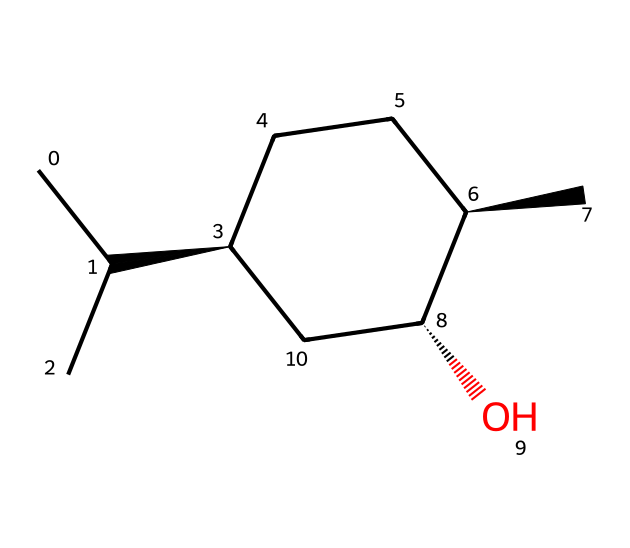What is the molecular formula of menthol? To find the molecular formula, we count the number of each type of atom present in the structure: there are 10 carbon atoms, 20 hydrogen atoms, and 1 oxygen atom, leading to the formula C10H20O.
Answer: C10H20O How many stereocenters are present in this molecule? A stereocenter is a carbon atom bonded to four different substituents. Looking at the structure, there are three carbon atoms (identified by their connectivity) where this condition is met, indicating 3 stereocenters.
Answer: 3 What functional group is present in menthol? By examining the structure, we note the presence of an -OH group (hydroxyl group) attached to one of the carbon atoms, which is characteristic of alcohols.
Answer: hydroxyl What is the structural characteristic that gives menthol its cooling effect? The cooling effect of menthol is primarily due to its structure and the presence of the hydroxyl group, which interacts with menthol receptors in the skin and mucous membranes, creating a sensation of coolness.
Answer: hydroxyl group What type of isomerism is exhibited by menthol? Menthol exhibits stereoisomerism due to the presence of stereocenters; this means it can exist in different configurations (enantiomers), which have different spatial arrangements.
Answer: stereoisomerism How many rings are in the structure of menthol? Upon examining the chemical structure, we can see that it has one cyclohexane ring, which is a six-membered carbon ring.
Answer: 1 